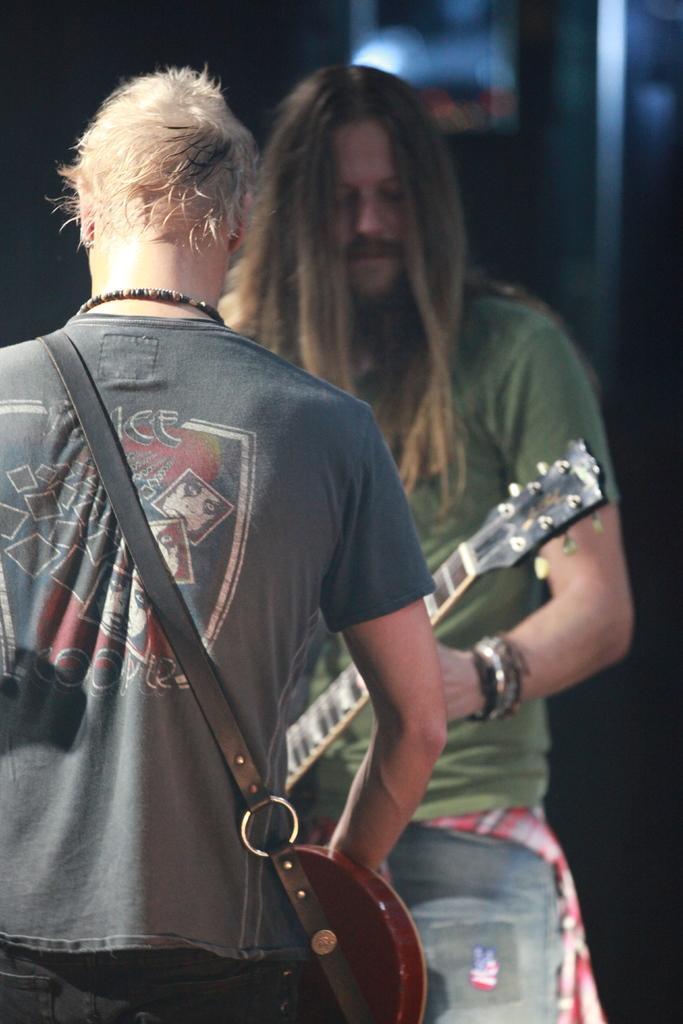Could you give a brief overview of what you see in this image? In this picture there are two men standing in front of each other. One guy is playing a guitar and other one is holding one of musical instrument across his shoulders. 